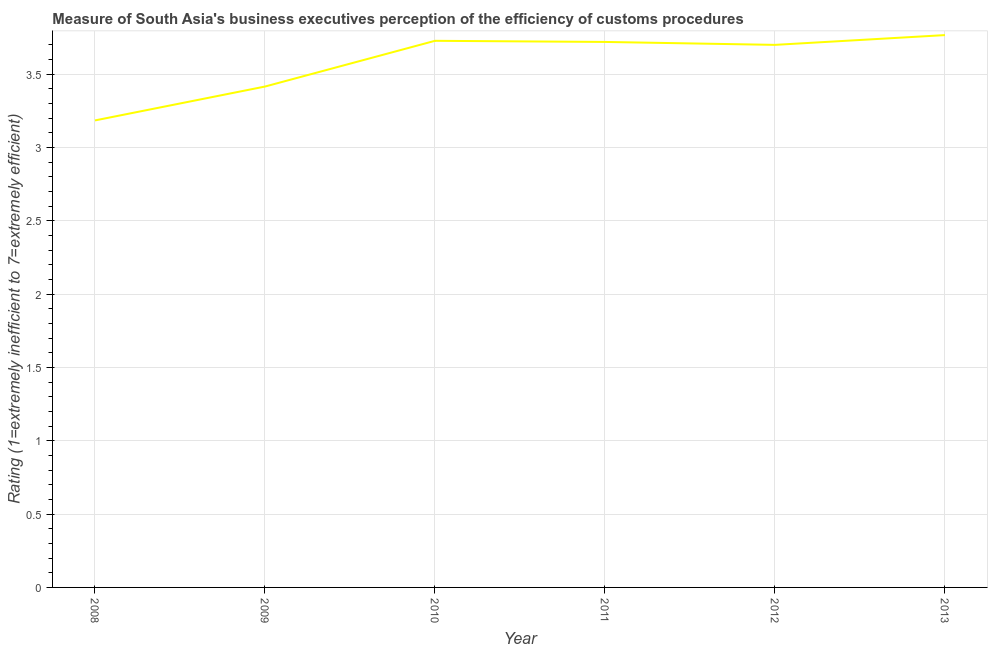What is the rating measuring burden of customs procedure in 2011?
Give a very brief answer. 3.72. Across all years, what is the maximum rating measuring burden of customs procedure?
Make the answer very short. 3.77. Across all years, what is the minimum rating measuring burden of customs procedure?
Give a very brief answer. 3.18. In which year was the rating measuring burden of customs procedure maximum?
Give a very brief answer. 2013. What is the sum of the rating measuring burden of customs procedure?
Provide a succinct answer. 21.51. What is the difference between the rating measuring burden of customs procedure in 2011 and 2012?
Provide a short and direct response. 0.02. What is the average rating measuring burden of customs procedure per year?
Your answer should be compact. 3.59. What is the median rating measuring burden of customs procedure?
Ensure brevity in your answer.  3.71. Do a majority of the years between 2011 and 2008 (inclusive) have rating measuring burden of customs procedure greater than 2.2 ?
Make the answer very short. Yes. What is the ratio of the rating measuring burden of customs procedure in 2010 to that in 2013?
Your answer should be compact. 0.99. Is the rating measuring burden of customs procedure in 2008 less than that in 2010?
Offer a very short reply. Yes. Is the difference between the rating measuring burden of customs procedure in 2011 and 2012 greater than the difference between any two years?
Offer a very short reply. No. What is the difference between the highest and the second highest rating measuring burden of customs procedure?
Provide a short and direct response. 0.04. What is the difference between the highest and the lowest rating measuring burden of customs procedure?
Keep it short and to the point. 0.58. In how many years, is the rating measuring burden of customs procedure greater than the average rating measuring burden of customs procedure taken over all years?
Ensure brevity in your answer.  4. Does the rating measuring burden of customs procedure monotonically increase over the years?
Provide a short and direct response. No. How many lines are there?
Offer a terse response. 1. How many years are there in the graph?
Give a very brief answer. 6. Does the graph contain any zero values?
Ensure brevity in your answer.  No. Does the graph contain grids?
Offer a very short reply. Yes. What is the title of the graph?
Provide a succinct answer. Measure of South Asia's business executives perception of the efficiency of customs procedures. What is the label or title of the Y-axis?
Provide a succinct answer. Rating (1=extremely inefficient to 7=extremely efficient). What is the Rating (1=extremely inefficient to 7=extremely efficient) in 2008?
Offer a very short reply. 3.18. What is the Rating (1=extremely inefficient to 7=extremely efficient) of 2009?
Offer a terse response. 3.42. What is the Rating (1=extremely inefficient to 7=extremely efficient) of 2010?
Offer a terse response. 3.73. What is the Rating (1=extremely inefficient to 7=extremely efficient) of 2011?
Ensure brevity in your answer.  3.72. What is the Rating (1=extremely inefficient to 7=extremely efficient) of 2012?
Ensure brevity in your answer.  3.7. What is the Rating (1=extremely inefficient to 7=extremely efficient) of 2013?
Give a very brief answer. 3.77. What is the difference between the Rating (1=extremely inefficient to 7=extremely efficient) in 2008 and 2009?
Your answer should be very brief. -0.23. What is the difference between the Rating (1=extremely inefficient to 7=extremely efficient) in 2008 and 2010?
Your answer should be very brief. -0.54. What is the difference between the Rating (1=extremely inefficient to 7=extremely efficient) in 2008 and 2011?
Keep it short and to the point. -0.54. What is the difference between the Rating (1=extremely inefficient to 7=extremely efficient) in 2008 and 2012?
Provide a short and direct response. -0.52. What is the difference between the Rating (1=extremely inefficient to 7=extremely efficient) in 2008 and 2013?
Offer a terse response. -0.58. What is the difference between the Rating (1=extremely inefficient to 7=extremely efficient) in 2009 and 2010?
Give a very brief answer. -0.31. What is the difference between the Rating (1=extremely inefficient to 7=extremely efficient) in 2009 and 2011?
Provide a succinct answer. -0.3. What is the difference between the Rating (1=extremely inefficient to 7=extremely efficient) in 2009 and 2012?
Ensure brevity in your answer.  -0.28. What is the difference between the Rating (1=extremely inefficient to 7=extremely efficient) in 2009 and 2013?
Your answer should be very brief. -0.35. What is the difference between the Rating (1=extremely inefficient to 7=extremely efficient) in 2010 and 2011?
Your answer should be very brief. 0.01. What is the difference between the Rating (1=extremely inefficient to 7=extremely efficient) in 2010 and 2012?
Ensure brevity in your answer.  0.03. What is the difference between the Rating (1=extremely inefficient to 7=extremely efficient) in 2010 and 2013?
Keep it short and to the point. -0.04. What is the difference between the Rating (1=extremely inefficient to 7=extremely efficient) in 2011 and 2012?
Your answer should be very brief. 0.02. What is the difference between the Rating (1=extremely inefficient to 7=extremely efficient) in 2011 and 2013?
Offer a very short reply. -0.05. What is the difference between the Rating (1=extremely inefficient to 7=extremely efficient) in 2012 and 2013?
Provide a short and direct response. -0.07. What is the ratio of the Rating (1=extremely inefficient to 7=extremely efficient) in 2008 to that in 2009?
Provide a short and direct response. 0.93. What is the ratio of the Rating (1=extremely inefficient to 7=extremely efficient) in 2008 to that in 2010?
Your answer should be very brief. 0.85. What is the ratio of the Rating (1=extremely inefficient to 7=extremely efficient) in 2008 to that in 2011?
Provide a succinct answer. 0.86. What is the ratio of the Rating (1=extremely inefficient to 7=extremely efficient) in 2008 to that in 2012?
Offer a terse response. 0.86. What is the ratio of the Rating (1=extremely inefficient to 7=extremely efficient) in 2008 to that in 2013?
Ensure brevity in your answer.  0.85. What is the ratio of the Rating (1=extremely inefficient to 7=extremely efficient) in 2009 to that in 2010?
Offer a very short reply. 0.92. What is the ratio of the Rating (1=extremely inefficient to 7=extremely efficient) in 2009 to that in 2011?
Make the answer very short. 0.92. What is the ratio of the Rating (1=extremely inefficient to 7=extremely efficient) in 2009 to that in 2012?
Make the answer very short. 0.92. What is the ratio of the Rating (1=extremely inefficient to 7=extremely efficient) in 2009 to that in 2013?
Your response must be concise. 0.91. What is the ratio of the Rating (1=extremely inefficient to 7=extremely efficient) in 2010 to that in 2011?
Keep it short and to the point. 1. What is the ratio of the Rating (1=extremely inefficient to 7=extremely efficient) in 2010 to that in 2012?
Offer a very short reply. 1.01. What is the ratio of the Rating (1=extremely inefficient to 7=extremely efficient) in 2010 to that in 2013?
Provide a succinct answer. 0.99. 